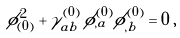Convert formula to latex. <formula><loc_0><loc_0><loc_500><loc_500>\phi _ { ( 0 ) } ^ { 2 } + \gamma ^ { ( 0 ) } _ { a b } \, \phi ^ { ( 0 ) } _ { , a } \phi ^ { ( 0 ) } _ { , b } = 0 \, ,</formula> 